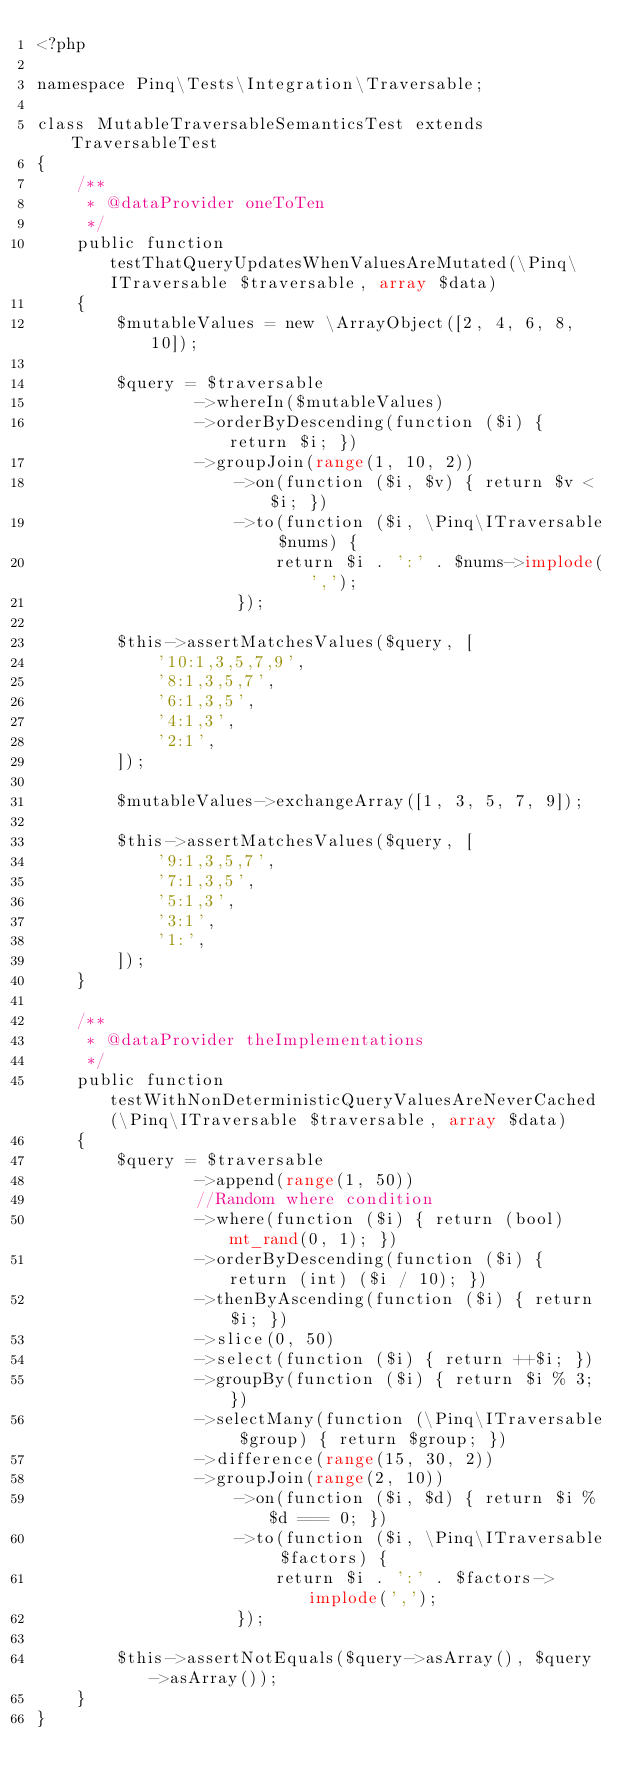Convert code to text. <code><loc_0><loc_0><loc_500><loc_500><_PHP_><?php

namespace Pinq\Tests\Integration\Traversable;

class MutableTraversableSemanticsTest extends TraversableTest
{
    /**
     * @dataProvider oneToTen
     */
    public function testThatQueryUpdatesWhenValuesAreMutated(\Pinq\ITraversable $traversable, array $data)
    {
        $mutableValues = new \ArrayObject([2, 4, 6, 8, 10]);

        $query = $traversable
                ->whereIn($mutableValues)
                ->orderByDescending(function ($i) { return $i; })
                ->groupJoin(range(1, 10, 2))
                    ->on(function ($i, $v) { return $v < $i; })
                    ->to(function ($i, \Pinq\ITraversable $nums) {
                        return $i . ':' . $nums->implode(',');
                    });

        $this->assertMatchesValues($query, [
            '10:1,3,5,7,9',
            '8:1,3,5,7',
            '6:1,3,5',
            '4:1,3',
            '2:1',
        ]);

        $mutableValues->exchangeArray([1, 3, 5, 7, 9]);

        $this->assertMatchesValues($query, [
            '9:1,3,5,7',
            '7:1,3,5',
            '5:1,3',
            '3:1',
            '1:',
        ]);
    }

    /**
     * @dataProvider theImplementations
     */
    public function testWithNonDeterministicQueryValuesAreNeverCached(\Pinq\ITraversable $traversable, array $data)
    {
        $query = $traversable
                ->append(range(1, 50))
                //Random where condition
                ->where(function ($i) { return (bool) mt_rand(0, 1); })
                ->orderByDescending(function ($i) { return (int) ($i / 10); })
                ->thenByAscending(function ($i) { return $i; })
                ->slice(0, 50)
                ->select(function ($i) { return ++$i; })
                ->groupBy(function ($i) { return $i % 3; })
                ->selectMany(function (\Pinq\ITraversable $group) { return $group; })
                ->difference(range(15, 30, 2))
                ->groupJoin(range(2, 10))
                    ->on(function ($i, $d) { return $i % $d === 0; })
                    ->to(function ($i, \Pinq\ITraversable $factors) {
                        return $i . ':' . $factors->implode(',');
                    });

        $this->assertNotEquals($query->asArray(), $query->asArray());
    }
}
</code> 